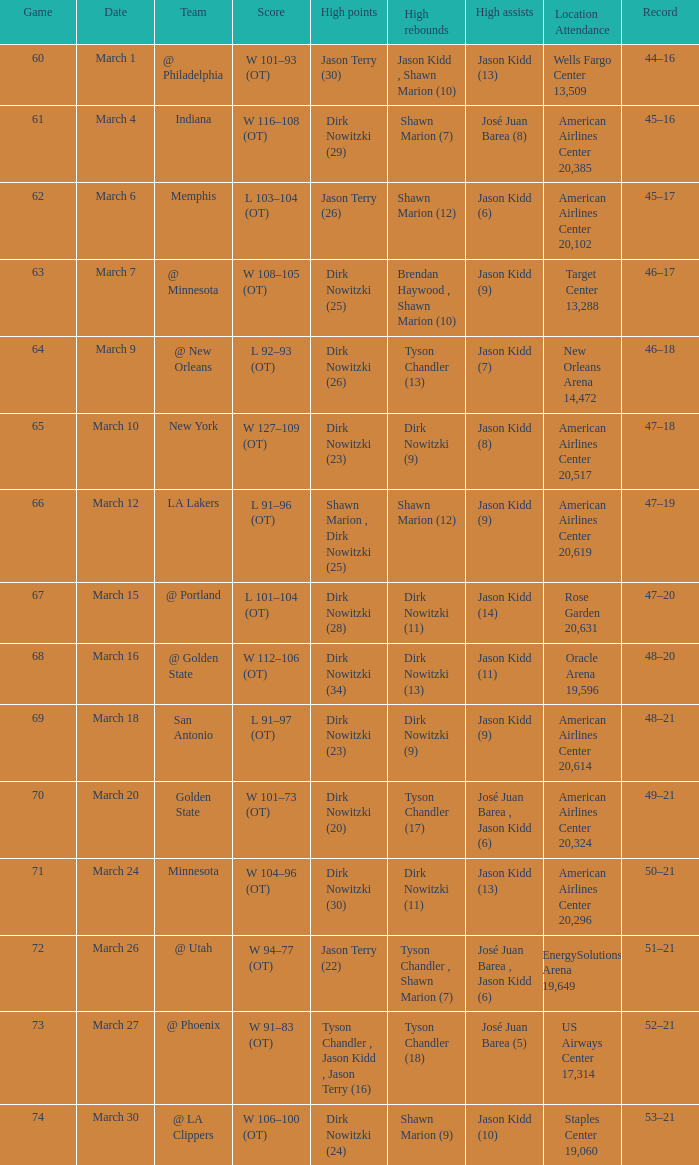Can you list the significant moments from march 30? Dirk Nowitzki (24). 